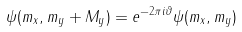<formula> <loc_0><loc_0><loc_500><loc_500>\psi ( m _ { x } , m _ { y } + M _ { y } ) = e ^ { - 2 \pi i \vartheta } \psi ( m _ { x } , m _ { y } )</formula> 